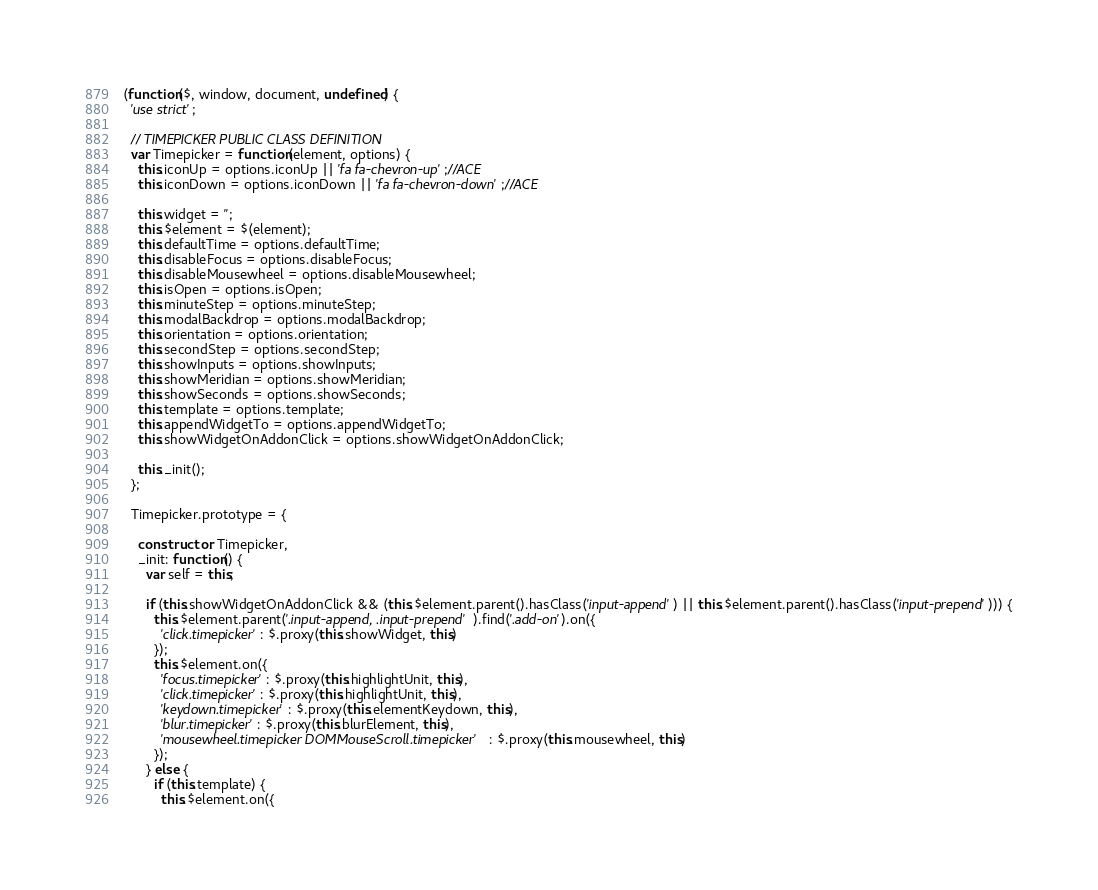<code> <loc_0><loc_0><loc_500><loc_500><_JavaScript_>(function($, window, document, undefined) {
  'use strict';

  // TIMEPICKER PUBLIC CLASS DEFINITION
  var Timepicker = function(element, options) {
  	this.iconUp = options.iconUp || 'fa fa-chevron-up';//ACE
	this.iconDown = options.iconDown || 'fa fa-chevron-down';//ACE

    this.widget = '';
    this.$element = $(element);
    this.defaultTime = options.defaultTime;
    this.disableFocus = options.disableFocus;
    this.disableMousewheel = options.disableMousewheel;
    this.isOpen = options.isOpen;
    this.minuteStep = options.minuteStep;
    this.modalBackdrop = options.modalBackdrop;
    this.orientation = options.orientation;
    this.secondStep = options.secondStep;
    this.showInputs = options.showInputs;
    this.showMeridian = options.showMeridian;
    this.showSeconds = options.showSeconds;
    this.template = options.template;
    this.appendWidgetTo = options.appendWidgetTo;
    this.showWidgetOnAddonClick = options.showWidgetOnAddonClick;

    this._init();
  };

  Timepicker.prototype = {

    constructor: Timepicker,
    _init: function() {
      var self = this;

      if (this.showWidgetOnAddonClick && (this.$element.parent().hasClass('input-append') || this.$element.parent().hasClass('input-prepend'))) {
        this.$element.parent('.input-append, .input-prepend').find('.add-on').on({
          'click.timepicker': $.proxy(this.showWidget, this)
        });
        this.$element.on({
          'focus.timepicker': $.proxy(this.highlightUnit, this),
          'click.timepicker': $.proxy(this.highlightUnit, this),
          'keydown.timepicker': $.proxy(this.elementKeydown, this),
          'blur.timepicker': $.proxy(this.blurElement, this),
          'mousewheel.timepicker DOMMouseScroll.timepicker': $.proxy(this.mousewheel, this)
        });
      } else {
        if (this.template) {
          this.$element.on({</code> 